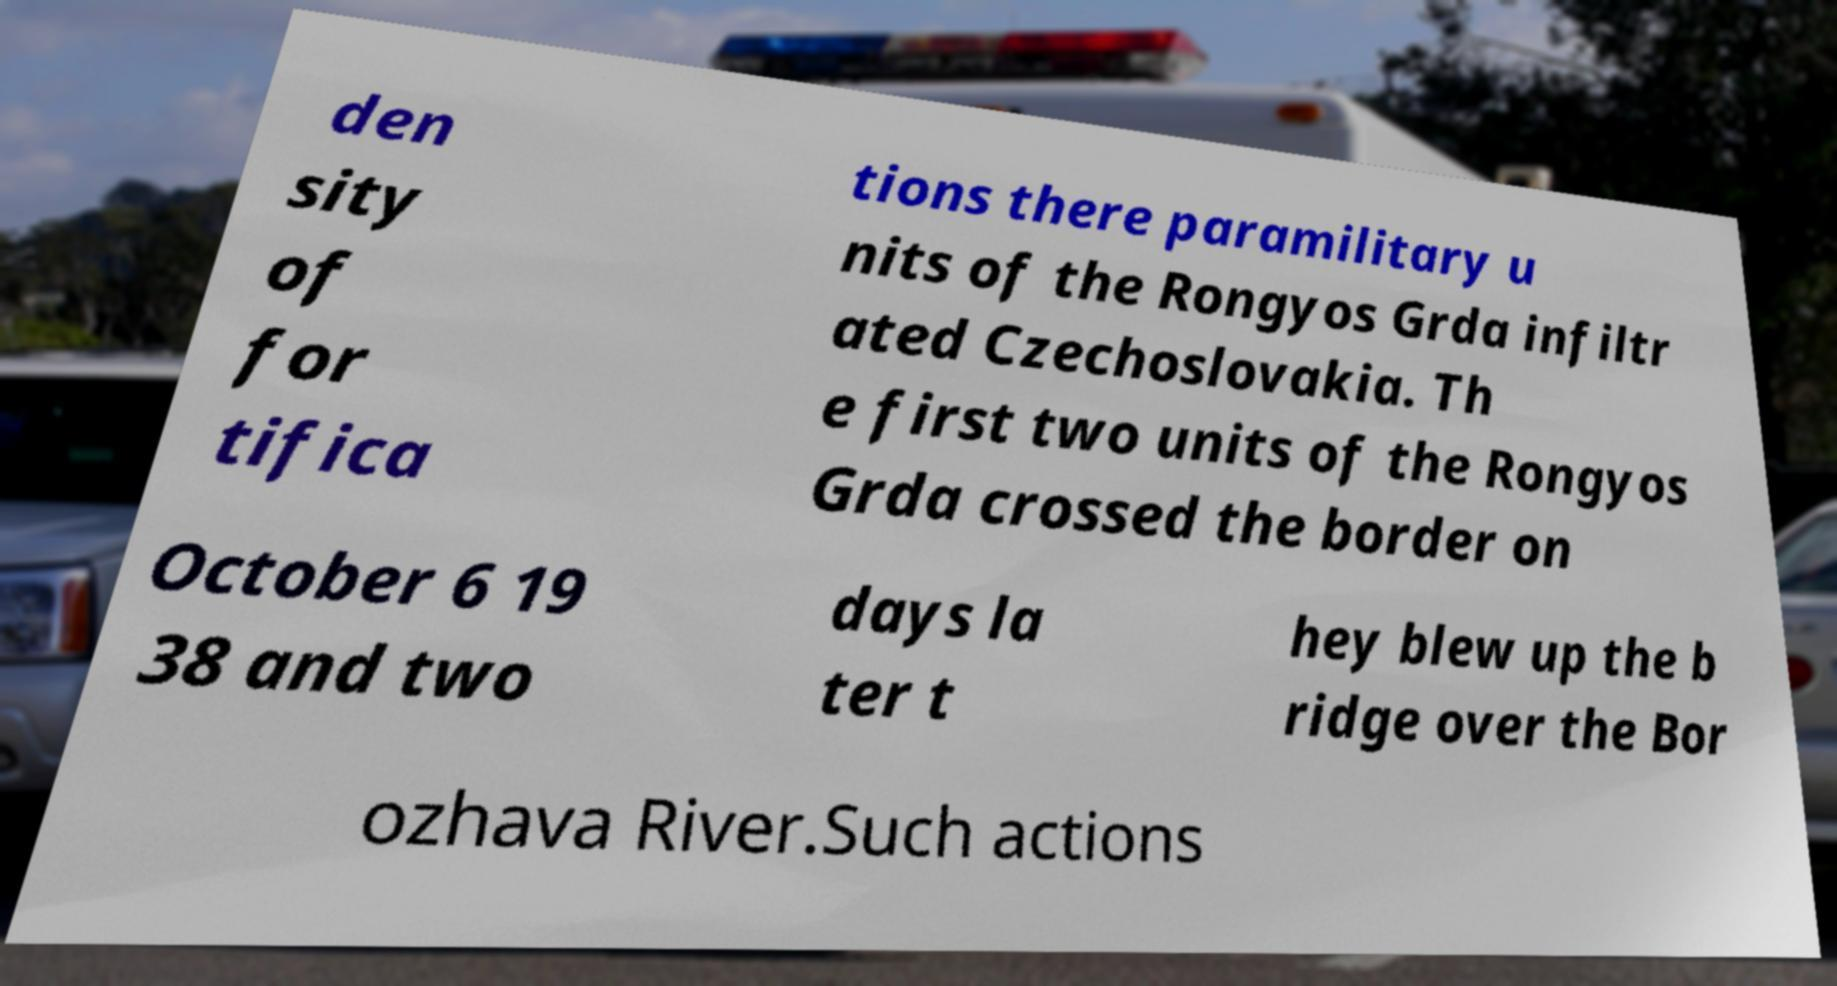For documentation purposes, I need the text within this image transcribed. Could you provide that? den sity of for tifica tions there paramilitary u nits of the Rongyos Grda infiltr ated Czechoslovakia. Th e first two units of the Rongyos Grda crossed the border on October 6 19 38 and two days la ter t hey blew up the b ridge over the Bor ozhava River.Such actions 